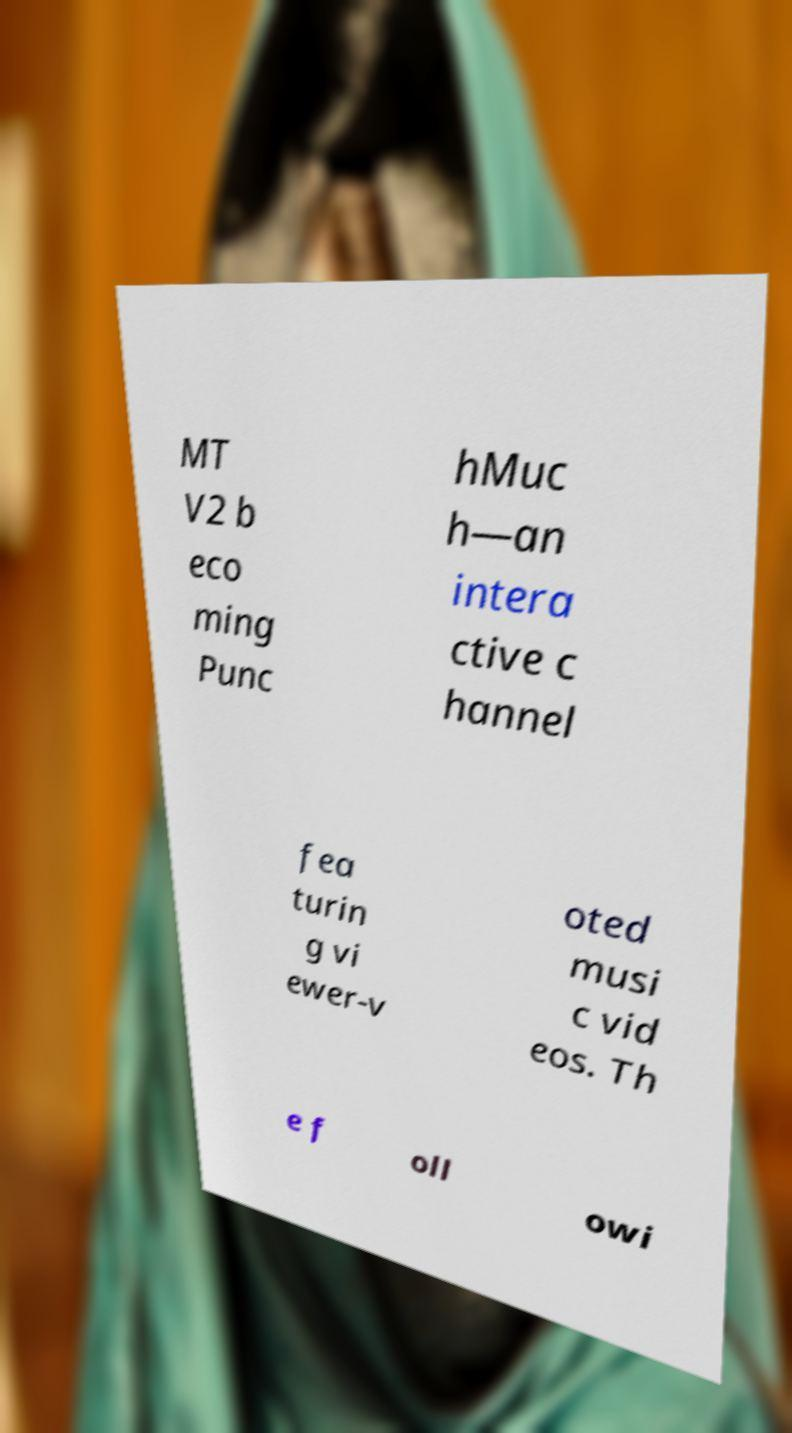Please identify and transcribe the text found in this image. MT V2 b eco ming Punc hMuc h—an intera ctive c hannel fea turin g vi ewer-v oted musi c vid eos. Th e f oll owi 